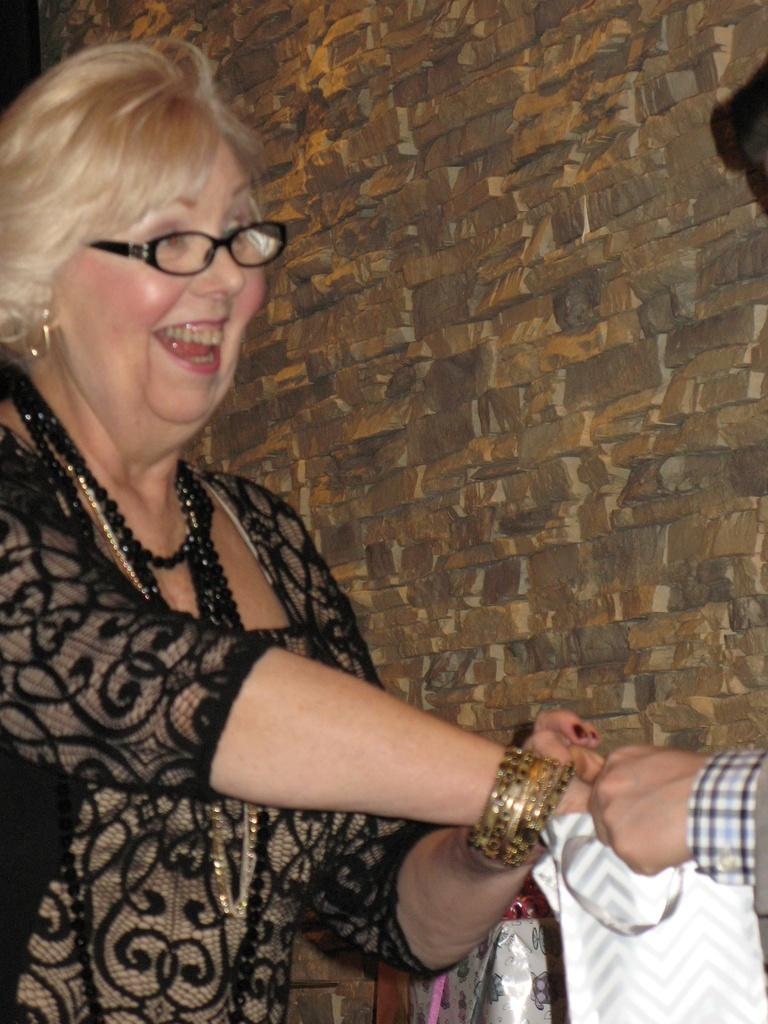Who is present in the image? There is a woman in the image. What is the woman's expression? The woman is smiling. Where is the human hand located in the image? The human hand is visible in the right side bottom corner of the image. What objects are near the human hand? There are objects near the human hand in the right side bottom corner of the image. What can be seen in the background of the image? There is a wall in the background of the image. What is the condition of the woman's chin in the image? There is no information about the woman's chin in the image, so it cannot be determined. What does the woman hope for in the image? There is no indication of the woman's hopes or desires in the image, so it cannot be determined. 